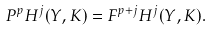Convert formula to latex. <formula><loc_0><loc_0><loc_500><loc_500>P ^ { p } H ^ { j } ( Y , K ) = F ^ { p + j } H ^ { j } ( Y , K ) .</formula> 